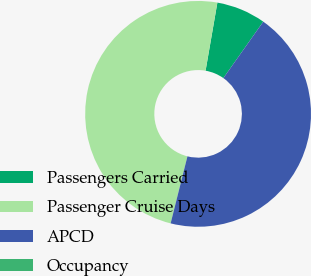Convert chart. <chart><loc_0><loc_0><loc_500><loc_500><pie_chart><fcel>Passengers Carried<fcel>Passenger Cruise Days<fcel>APCD<fcel>Occupancy<nl><fcel>7.06%<fcel>48.82%<fcel>44.12%<fcel>0.0%<nl></chart> 